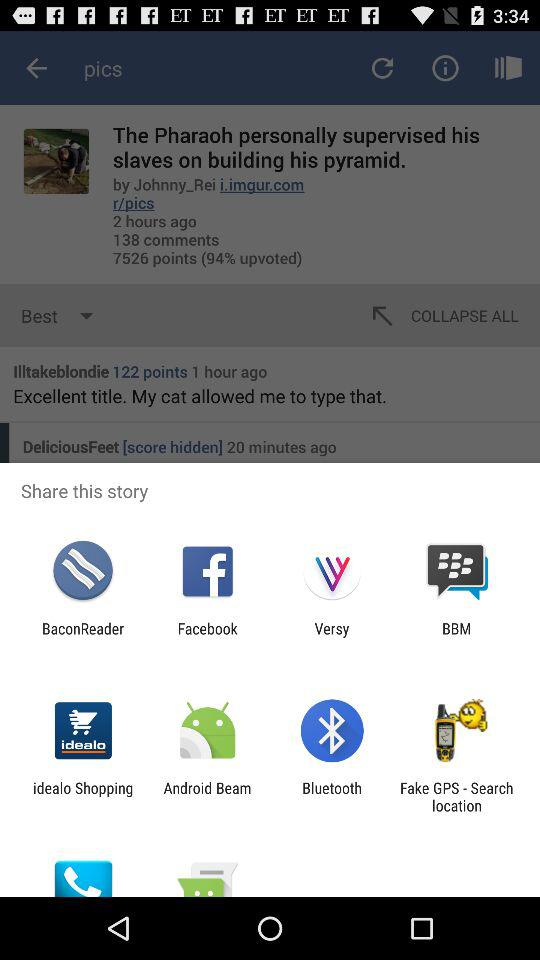By which app can we share this story? You can share this story by "BaconReader", "Facebook", "Versy", "BBM", "idealo Shopping", "Android Beam", "Bluetooth" and "Fake GPS - Search location". 